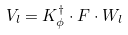<formula> <loc_0><loc_0><loc_500><loc_500>V _ { l } = K _ { \phi } ^ { \dagger } \cdot F \cdot W _ { l }</formula> 